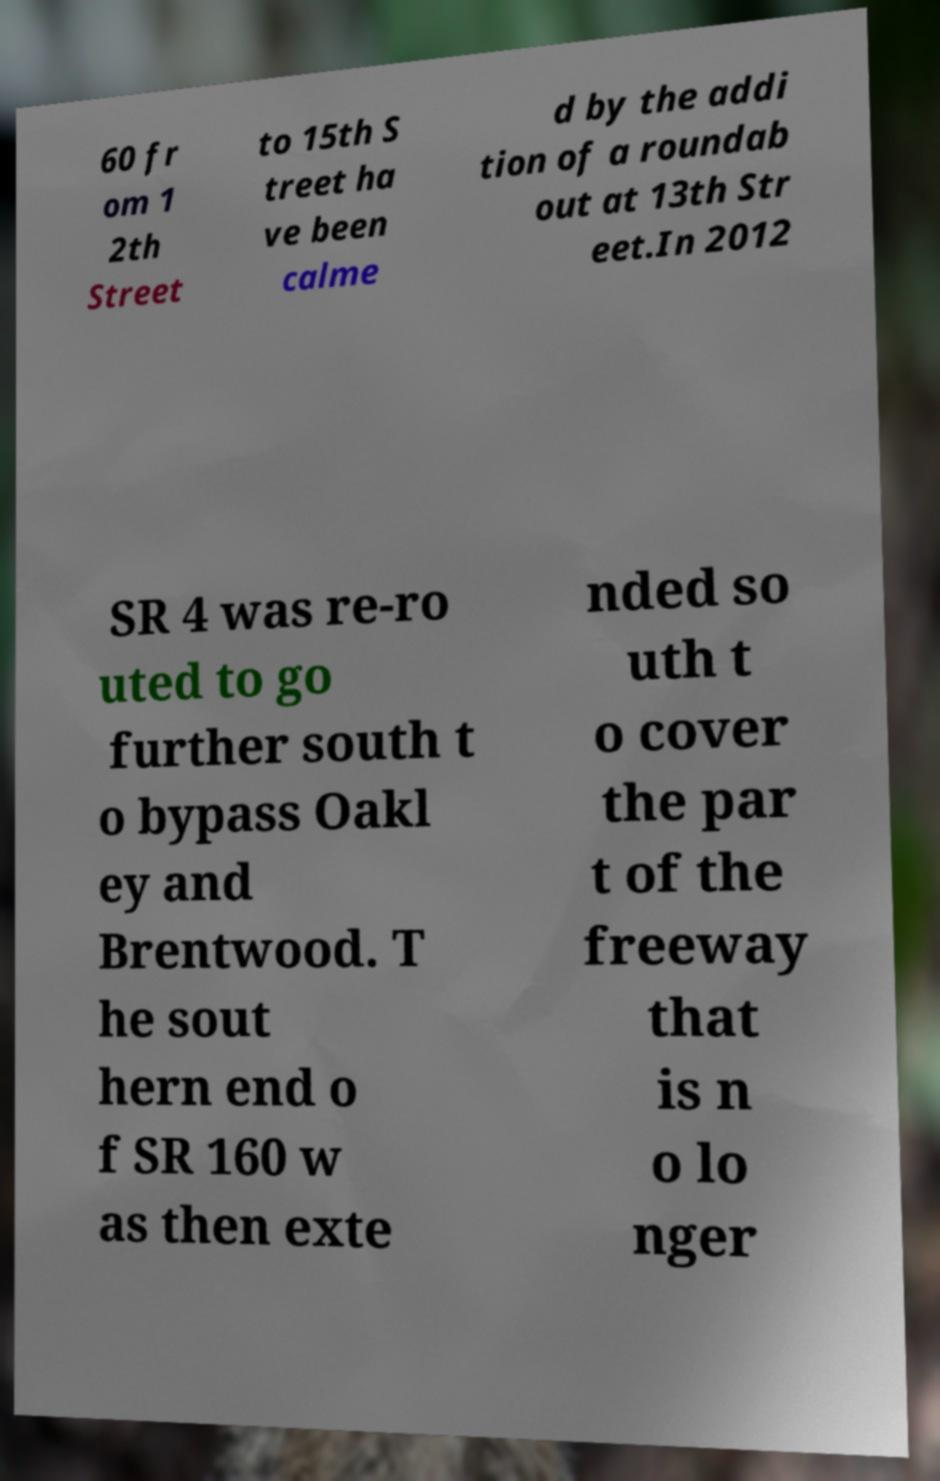For documentation purposes, I need the text within this image transcribed. Could you provide that? 60 fr om 1 2th Street to 15th S treet ha ve been calme d by the addi tion of a roundab out at 13th Str eet.In 2012 SR 4 was re-ro uted to go further south t o bypass Oakl ey and Brentwood. T he sout hern end o f SR 160 w as then exte nded so uth t o cover the par t of the freeway that is n o lo nger 